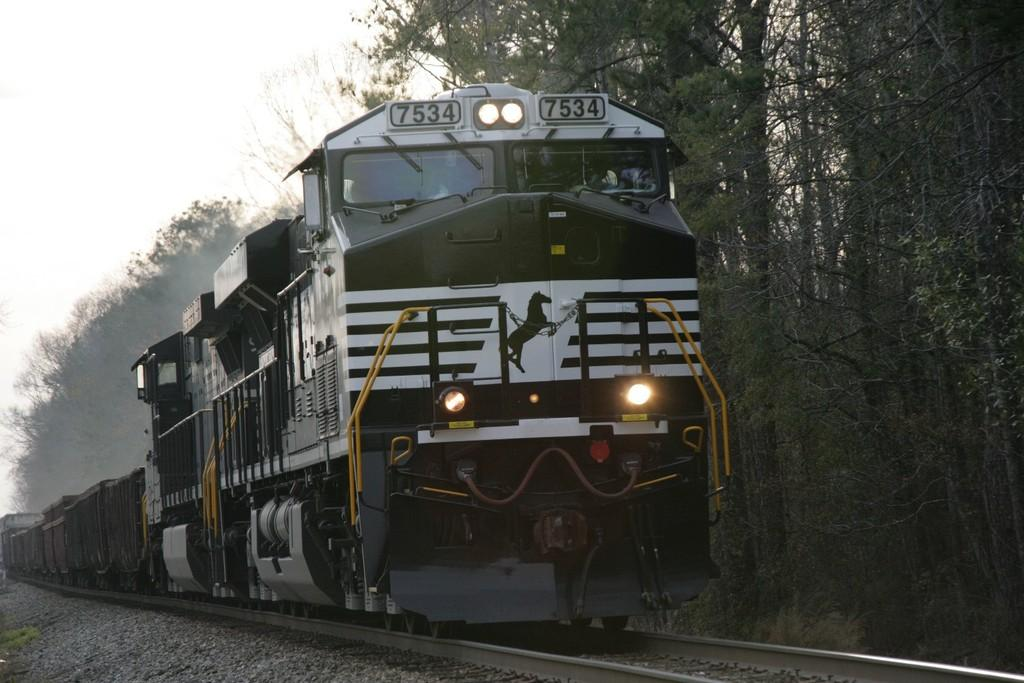What type of surface is visible in the image? There is ground visible in the image. What transportation feature can be seen on the ground? There is a railway track in the image. What is on the railway track? There is a train on the railway track. What colors are the train? The train is white and black in color. What can be seen in the background of the image? The sky and trees are visible in the background of the image. What type of spark can be seen coming from the leaves in the image? There are no leaves or sparks present in the image; it features a train on a railway track with a background of sky and trees. 